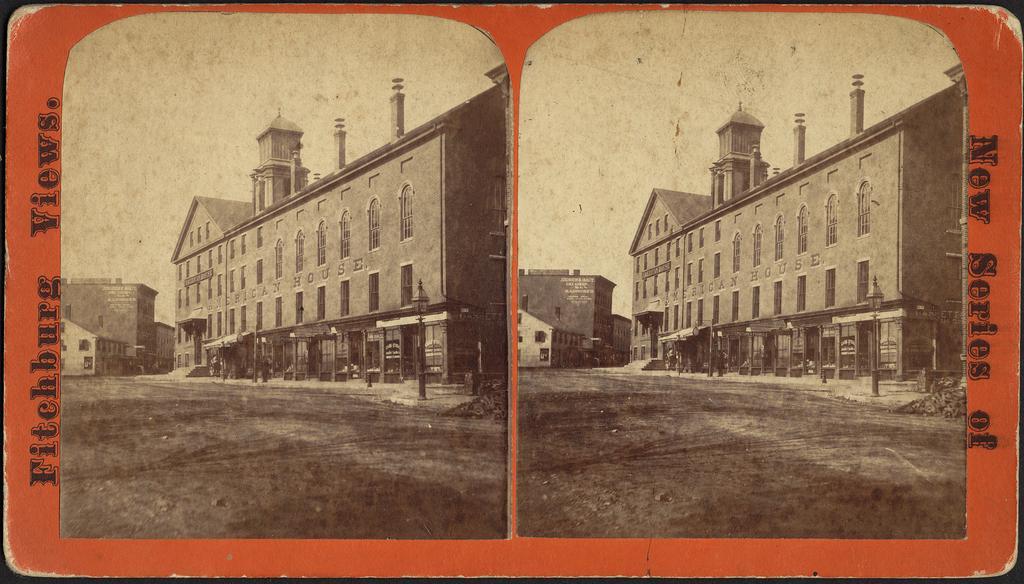In one or two sentences, can you explain what this image depicts? There are two photos in black and white color, it is a very big building named African house. At the top it is the sky. 